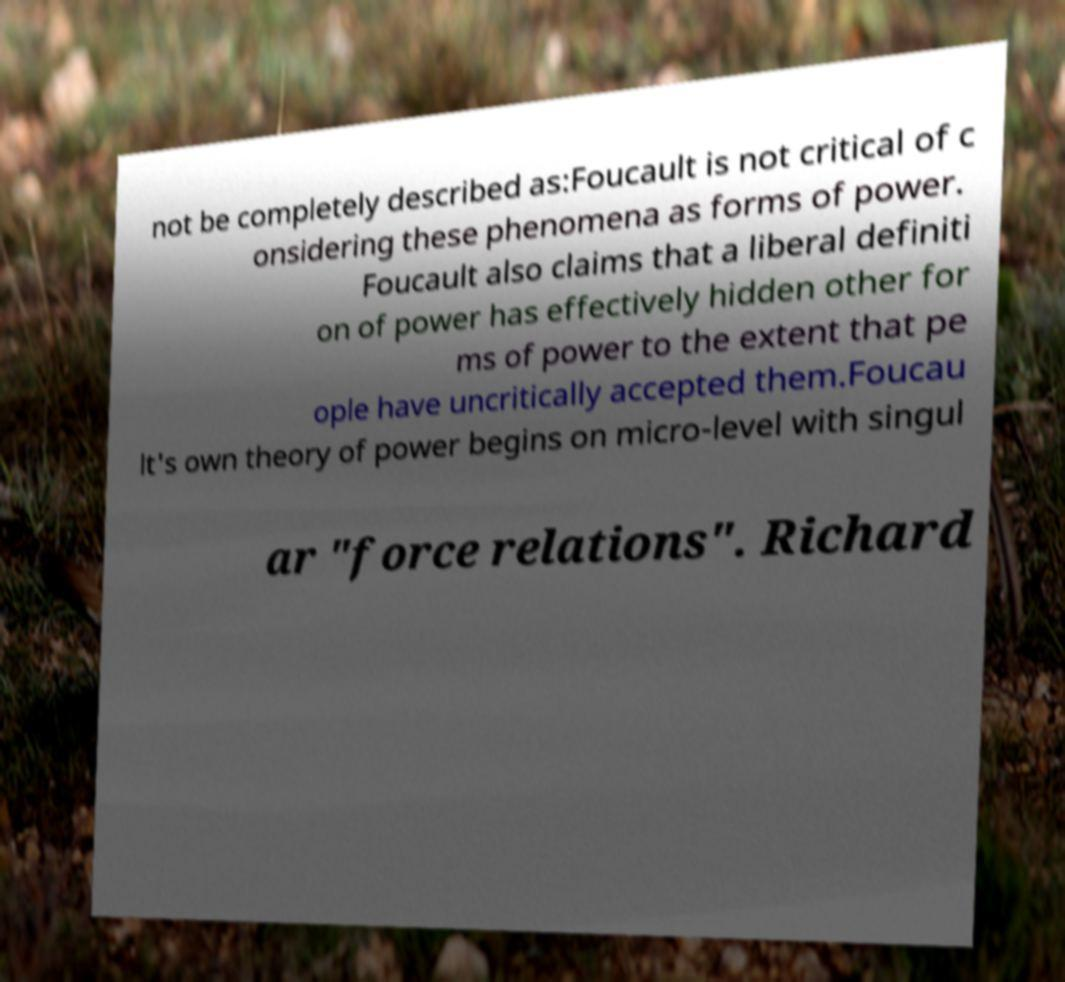Please identify and transcribe the text found in this image. not be completely described as:Foucault is not critical of c onsidering these phenomena as forms of power. Foucault also claims that a liberal definiti on of power has effectively hidden other for ms of power to the extent that pe ople have uncritically accepted them.Foucau lt's own theory of power begins on micro-level with singul ar "force relations". Richard 